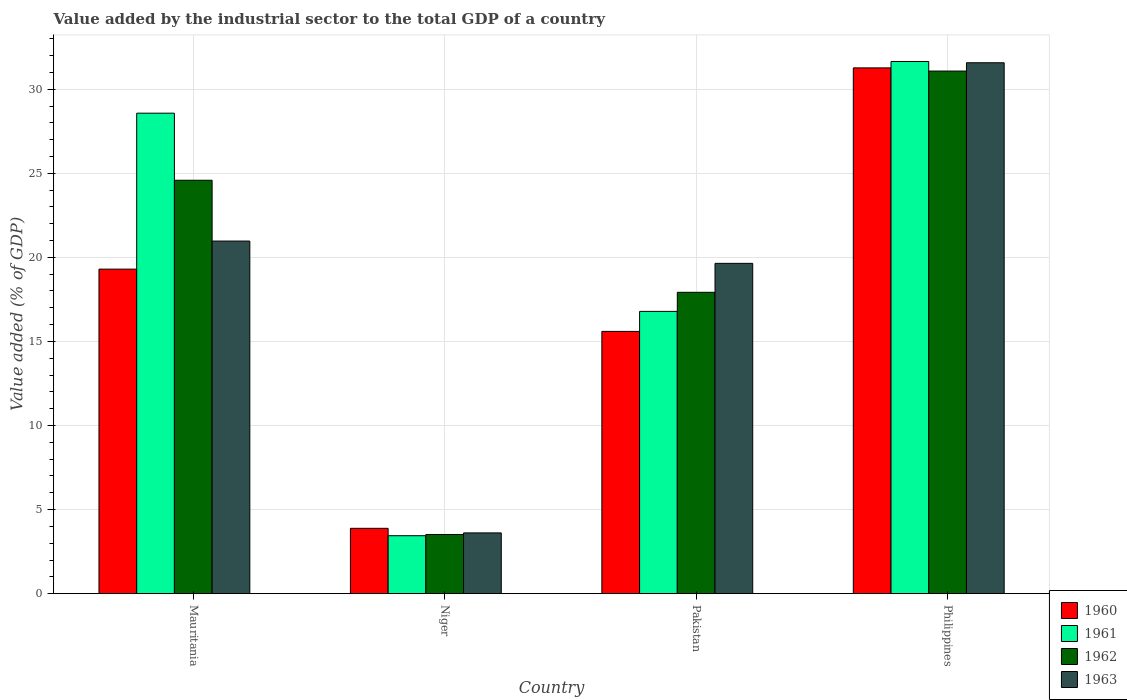How many different coloured bars are there?
Your response must be concise. 4. Are the number of bars per tick equal to the number of legend labels?
Make the answer very short. Yes. Are the number of bars on each tick of the X-axis equal?
Ensure brevity in your answer.  Yes. How many bars are there on the 4th tick from the left?
Your response must be concise. 4. What is the label of the 1st group of bars from the left?
Ensure brevity in your answer.  Mauritania. In how many cases, is the number of bars for a given country not equal to the number of legend labels?
Provide a succinct answer. 0. What is the value added by the industrial sector to the total GDP in 1961 in Niger?
Provide a succinct answer. 3.45. Across all countries, what is the maximum value added by the industrial sector to the total GDP in 1963?
Provide a short and direct response. 31.57. Across all countries, what is the minimum value added by the industrial sector to the total GDP in 1962?
Give a very brief answer. 3.52. In which country was the value added by the industrial sector to the total GDP in 1962 minimum?
Keep it short and to the point. Niger. What is the total value added by the industrial sector to the total GDP in 1960 in the graph?
Offer a terse response. 70.05. What is the difference between the value added by the industrial sector to the total GDP in 1961 in Niger and that in Pakistan?
Provide a short and direct response. -13.34. What is the difference between the value added by the industrial sector to the total GDP in 1963 in Niger and the value added by the industrial sector to the total GDP in 1960 in Philippines?
Offer a very short reply. -27.65. What is the average value added by the industrial sector to the total GDP in 1961 per country?
Ensure brevity in your answer.  20.11. What is the difference between the value added by the industrial sector to the total GDP of/in 1960 and value added by the industrial sector to the total GDP of/in 1963 in Niger?
Keep it short and to the point. 0.27. In how many countries, is the value added by the industrial sector to the total GDP in 1961 greater than 17 %?
Your answer should be very brief. 2. What is the ratio of the value added by the industrial sector to the total GDP in 1960 in Mauritania to that in Philippines?
Make the answer very short. 0.62. Is the difference between the value added by the industrial sector to the total GDP in 1960 in Pakistan and Philippines greater than the difference between the value added by the industrial sector to the total GDP in 1963 in Pakistan and Philippines?
Your answer should be compact. No. What is the difference between the highest and the second highest value added by the industrial sector to the total GDP in 1962?
Ensure brevity in your answer.  6.66. What is the difference between the highest and the lowest value added by the industrial sector to the total GDP in 1963?
Give a very brief answer. 27.96. In how many countries, is the value added by the industrial sector to the total GDP in 1961 greater than the average value added by the industrial sector to the total GDP in 1961 taken over all countries?
Your answer should be very brief. 2. Is the sum of the value added by the industrial sector to the total GDP in 1960 in Niger and Philippines greater than the maximum value added by the industrial sector to the total GDP in 1961 across all countries?
Make the answer very short. Yes. Is it the case that in every country, the sum of the value added by the industrial sector to the total GDP in 1961 and value added by the industrial sector to the total GDP in 1962 is greater than the sum of value added by the industrial sector to the total GDP in 1960 and value added by the industrial sector to the total GDP in 1963?
Give a very brief answer. No. What does the 1st bar from the left in Niger represents?
Your answer should be very brief. 1960. Is it the case that in every country, the sum of the value added by the industrial sector to the total GDP in 1960 and value added by the industrial sector to the total GDP in 1962 is greater than the value added by the industrial sector to the total GDP in 1963?
Your answer should be very brief. Yes. How many bars are there?
Offer a terse response. 16. Are all the bars in the graph horizontal?
Offer a terse response. No. Are the values on the major ticks of Y-axis written in scientific E-notation?
Offer a very short reply. No. Does the graph contain any zero values?
Provide a short and direct response. No. Does the graph contain grids?
Your answer should be very brief. Yes. Where does the legend appear in the graph?
Your answer should be compact. Bottom right. How many legend labels are there?
Your response must be concise. 4. What is the title of the graph?
Offer a terse response. Value added by the industrial sector to the total GDP of a country. Does "1994" appear as one of the legend labels in the graph?
Offer a very short reply. No. What is the label or title of the X-axis?
Keep it short and to the point. Country. What is the label or title of the Y-axis?
Your answer should be compact. Value added (% of GDP). What is the Value added (% of GDP) in 1960 in Mauritania?
Make the answer very short. 19.3. What is the Value added (% of GDP) in 1961 in Mauritania?
Ensure brevity in your answer.  28.57. What is the Value added (% of GDP) of 1962 in Mauritania?
Make the answer very short. 24.59. What is the Value added (% of GDP) of 1963 in Mauritania?
Offer a terse response. 20.97. What is the Value added (% of GDP) of 1960 in Niger?
Your response must be concise. 3.89. What is the Value added (% of GDP) of 1961 in Niger?
Give a very brief answer. 3.45. What is the Value added (% of GDP) in 1962 in Niger?
Provide a succinct answer. 3.52. What is the Value added (% of GDP) in 1963 in Niger?
Provide a succinct answer. 3.61. What is the Value added (% of GDP) of 1960 in Pakistan?
Your response must be concise. 15.6. What is the Value added (% of GDP) of 1961 in Pakistan?
Keep it short and to the point. 16.79. What is the Value added (% of GDP) in 1962 in Pakistan?
Your response must be concise. 17.92. What is the Value added (% of GDP) of 1963 in Pakistan?
Your response must be concise. 19.64. What is the Value added (% of GDP) of 1960 in Philippines?
Offer a very short reply. 31.27. What is the Value added (% of GDP) of 1961 in Philippines?
Give a very brief answer. 31.65. What is the Value added (% of GDP) in 1962 in Philippines?
Your answer should be compact. 31.08. What is the Value added (% of GDP) in 1963 in Philippines?
Offer a terse response. 31.57. Across all countries, what is the maximum Value added (% of GDP) in 1960?
Ensure brevity in your answer.  31.27. Across all countries, what is the maximum Value added (% of GDP) of 1961?
Your answer should be compact. 31.65. Across all countries, what is the maximum Value added (% of GDP) of 1962?
Your response must be concise. 31.08. Across all countries, what is the maximum Value added (% of GDP) in 1963?
Keep it short and to the point. 31.57. Across all countries, what is the minimum Value added (% of GDP) in 1960?
Offer a terse response. 3.89. Across all countries, what is the minimum Value added (% of GDP) of 1961?
Keep it short and to the point. 3.45. Across all countries, what is the minimum Value added (% of GDP) of 1962?
Provide a short and direct response. 3.52. Across all countries, what is the minimum Value added (% of GDP) of 1963?
Offer a terse response. 3.61. What is the total Value added (% of GDP) of 1960 in the graph?
Give a very brief answer. 70.05. What is the total Value added (% of GDP) in 1961 in the graph?
Offer a very short reply. 80.46. What is the total Value added (% of GDP) in 1962 in the graph?
Provide a succinct answer. 77.11. What is the total Value added (% of GDP) in 1963 in the graph?
Ensure brevity in your answer.  75.8. What is the difference between the Value added (% of GDP) of 1960 in Mauritania and that in Niger?
Offer a terse response. 15.41. What is the difference between the Value added (% of GDP) in 1961 in Mauritania and that in Niger?
Your answer should be very brief. 25.13. What is the difference between the Value added (% of GDP) in 1962 in Mauritania and that in Niger?
Your response must be concise. 21.07. What is the difference between the Value added (% of GDP) in 1963 in Mauritania and that in Niger?
Offer a very short reply. 17.36. What is the difference between the Value added (% of GDP) in 1960 in Mauritania and that in Pakistan?
Make the answer very short. 3.7. What is the difference between the Value added (% of GDP) of 1961 in Mauritania and that in Pakistan?
Ensure brevity in your answer.  11.79. What is the difference between the Value added (% of GDP) of 1962 in Mauritania and that in Pakistan?
Make the answer very short. 6.66. What is the difference between the Value added (% of GDP) in 1963 in Mauritania and that in Pakistan?
Provide a short and direct response. 1.33. What is the difference between the Value added (% of GDP) in 1960 in Mauritania and that in Philippines?
Ensure brevity in your answer.  -11.97. What is the difference between the Value added (% of GDP) of 1961 in Mauritania and that in Philippines?
Keep it short and to the point. -3.07. What is the difference between the Value added (% of GDP) in 1962 in Mauritania and that in Philippines?
Ensure brevity in your answer.  -6.49. What is the difference between the Value added (% of GDP) in 1963 in Mauritania and that in Philippines?
Your answer should be very brief. -10.6. What is the difference between the Value added (% of GDP) in 1960 in Niger and that in Pakistan?
Make the answer very short. -11.71. What is the difference between the Value added (% of GDP) of 1961 in Niger and that in Pakistan?
Provide a succinct answer. -13.34. What is the difference between the Value added (% of GDP) in 1962 in Niger and that in Pakistan?
Offer a very short reply. -14.4. What is the difference between the Value added (% of GDP) of 1963 in Niger and that in Pakistan?
Give a very brief answer. -16.03. What is the difference between the Value added (% of GDP) in 1960 in Niger and that in Philippines?
Give a very brief answer. -27.38. What is the difference between the Value added (% of GDP) of 1961 in Niger and that in Philippines?
Offer a terse response. -28.2. What is the difference between the Value added (% of GDP) in 1962 in Niger and that in Philippines?
Provide a short and direct response. -27.56. What is the difference between the Value added (% of GDP) of 1963 in Niger and that in Philippines?
Provide a succinct answer. -27.96. What is the difference between the Value added (% of GDP) in 1960 in Pakistan and that in Philippines?
Make the answer very short. -15.67. What is the difference between the Value added (% of GDP) in 1961 in Pakistan and that in Philippines?
Ensure brevity in your answer.  -14.86. What is the difference between the Value added (% of GDP) in 1962 in Pakistan and that in Philippines?
Provide a succinct answer. -13.16. What is the difference between the Value added (% of GDP) in 1963 in Pakistan and that in Philippines?
Keep it short and to the point. -11.93. What is the difference between the Value added (% of GDP) in 1960 in Mauritania and the Value added (% of GDP) in 1961 in Niger?
Ensure brevity in your answer.  15.85. What is the difference between the Value added (% of GDP) of 1960 in Mauritania and the Value added (% of GDP) of 1962 in Niger?
Your answer should be very brief. 15.78. What is the difference between the Value added (% of GDP) in 1960 in Mauritania and the Value added (% of GDP) in 1963 in Niger?
Make the answer very short. 15.69. What is the difference between the Value added (% of GDP) of 1961 in Mauritania and the Value added (% of GDP) of 1962 in Niger?
Provide a succinct answer. 25.05. What is the difference between the Value added (% of GDP) of 1961 in Mauritania and the Value added (% of GDP) of 1963 in Niger?
Offer a terse response. 24.96. What is the difference between the Value added (% of GDP) in 1962 in Mauritania and the Value added (% of GDP) in 1963 in Niger?
Your response must be concise. 20.97. What is the difference between the Value added (% of GDP) of 1960 in Mauritania and the Value added (% of GDP) of 1961 in Pakistan?
Offer a terse response. 2.51. What is the difference between the Value added (% of GDP) of 1960 in Mauritania and the Value added (% of GDP) of 1962 in Pakistan?
Your answer should be compact. 1.38. What is the difference between the Value added (% of GDP) in 1960 in Mauritania and the Value added (% of GDP) in 1963 in Pakistan?
Offer a terse response. -0.34. What is the difference between the Value added (% of GDP) of 1961 in Mauritania and the Value added (% of GDP) of 1962 in Pakistan?
Make the answer very short. 10.65. What is the difference between the Value added (% of GDP) in 1961 in Mauritania and the Value added (% of GDP) in 1963 in Pakistan?
Give a very brief answer. 8.93. What is the difference between the Value added (% of GDP) of 1962 in Mauritania and the Value added (% of GDP) of 1963 in Pakistan?
Give a very brief answer. 4.94. What is the difference between the Value added (% of GDP) of 1960 in Mauritania and the Value added (% of GDP) of 1961 in Philippines?
Provide a short and direct response. -12.35. What is the difference between the Value added (% of GDP) of 1960 in Mauritania and the Value added (% of GDP) of 1962 in Philippines?
Your answer should be very brief. -11.78. What is the difference between the Value added (% of GDP) in 1960 in Mauritania and the Value added (% of GDP) in 1963 in Philippines?
Your answer should be very brief. -12.27. What is the difference between the Value added (% of GDP) in 1961 in Mauritania and the Value added (% of GDP) in 1962 in Philippines?
Make the answer very short. -2.51. What is the difference between the Value added (% of GDP) in 1961 in Mauritania and the Value added (% of GDP) in 1963 in Philippines?
Give a very brief answer. -3. What is the difference between the Value added (% of GDP) in 1962 in Mauritania and the Value added (% of GDP) in 1963 in Philippines?
Offer a terse response. -6.99. What is the difference between the Value added (% of GDP) of 1960 in Niger and the Value added (% of GDP) of 1961 in Pakistan?
Your answer should be very brief. -12.9. What is the difference between the Value added (% of GDP) of 1960 in Niger and the Value added (% of GDP) of 1962 in Pakistan?
Your response must be concise. -14.04. What is the difference between the Value added (% of GDP) of 1960 in Niger and the Value added (% of GDP) of 1963 in Pakistan?
Your response must be concise. -15.76. What is the difference between the Value added (% of GDP) of 1961 in Niger and the Value added (% of GDP) of 1962 in Pakistan?
Provide a short and direct response. -14.48. What is the difference between the Value added (% of GDP) of 1961 in Niger and the Value added (% of GDP) of 1963 in Pakistan?
Make the answer very short. -16.2. What is the difference between the Value added (% of GDP) in 1962 in Niger and the Value added (% of GDP) in 1963 in Pakistan?
Provide a succinct answer. -16.12. What is the difference between the Value added (% of GDP) of 1960 in Niger and the Value added (% of GDP) of 1961 in Philippines?
Your answer should be very brief. -27.76. What is the difference between the Value added (% of GDP) in 1960 in Niger and the Value added (% of GDP) in 1962 in Philippines?
Your response must be concise. -27.19. What is the difference between the Value added (% of GDP) of 1960 in Niger and the Value added (% of GDP) of 1963 in Philippines?
Make the answer very short. -27.69. What is the difference between the Value added (% of GDP) in 1961 in Niger and the Value added (% of GDP) in 1962 in Philippines?
Give a very brief answer. -27.63. What is the difference between the Value added (% of GDP) of 1961 in Niger and the Value added (% of GDP) of 1963 in Philippines?
Offer a terse response. -28.13. What is the difference between the Value added (% of GDP) in 1962 in Niger and the Value added (% of GDP) in 1963 in Philippines?
Offer a very short reply. -28.05. What is the difference between the Value added (% of GDP) in 1960 in Pakistan and the Value added (% of GDP) in 1961 in Philippines?
Provide a succinct answer. -16.05. What is the difference between the Value added (% of GDP) of 1960 in Pakistan and the Value added (% of GDP) of 1962 in Philippines?
Provide a short and direct response. -15.48. What is the difference between the Value added (% of GDP) in 1960 in Pakistan and the Value added (% of GDP) in 1963 in Philippines?
Offer a very short reply. -15.98. What is the difference between the Value added (% of GDP) of 1961 in Pakistan and the Value added (% of GDP) of 1962 in Philippines?
Make the answer very short. -14.29. What is the difference between the Value added (% of GDP) in 1961 in Pakistan and the Value added (% of GDP) in 1963 in Philippines?
Make the answer very short. -14.79. What is the difference between the Value added (% of GDP) of 1962 in Pakistan and the Value added (% of GDP) of 1963 in Philippines?
Provide a short and direct response. -13.65. What is the average Value added (% of GDP) of 1960 per country?
Your answer should be compact. 17.51. What is the average Value added (% of GDP) in 1961 per country?
Keep it short and to the point. 20.11. What is the average Value added (% of GDP) of 1962 per country?
Offer a very short reply. 19.28. What is the average Value added (% of GDP) of 1963 per country?
Provide a succinct answer. 18.95. What is the difference between the Value added (% of GDP) in 1960 and Value added (% of GDP) in 1961 in Mauritania?
Provide a short and direct response. -9.27. What is the difference between the Value added (% of GDP) in 1960 and Value added (% of GDP) in 1962 in Mauritania?
Your answer should be compact. -5.29. What is the difference between the Value added (% of GDP) of 1960 and Value added (% of GDP) of 1963 in Mauritania?
Your answer should be very brief. -1.67. What is the difference between the Value added (% of GDP) of 1961 and Value added (% of GDP) of 1962 in Mauritania?
Give a very brief answer. 3.99. What is the difference between the Value added (% of GDP) in 1961 and Value added (% of GDP) in 1963 in Mauritania?
Your response must be concise. 7.6. What is the difference between the Value added (% of GDP) of 1962 and Value added (% of GDP) of 1963 in Mauritania?
Provide a succinct answer. 3.62. What is the difference between the Value added (% of GDP) of 1960 and Value added (% of GDP) of 1961 in Niger?
Keep it short and to the point. 0.44. What is the difference between the Value added (% of GDP) of 1960 and Value added (% of GDP) of 1962 in Niger?
Provide a short and direct response. 0.37. What is the difference between the Value added (% of GDP) of 1960 and Value added (% of GDP) of 1963 in Niger?
Make the answer very short. 0.27. What is the difference between the Value added (% of GDP) of 1961 and Value added (% of GDP) of 1962 in Niger?
Provide a short and direct response. -0.07. What is the difference between the Value added (% of GDP) of 1961 and Value added (% of GDP) of 1963 in Niger?
Provide a short and direct response. -0.17. What is the difference between the Value added (% of GDP) of 1962 and Value added (% of GDP) of 1963 in Niger?
Your answer should be very brief. -0.09. What is the difference between the Value added (% of GDP) in 1960 and Value added (% of GDP) in 1961 in Pakistan?
Keep it short and to the point. -1.19. What is the difference between the Value added (% of GDP) of 1960 and Value added (% of GDP) of 1962 in Pakistan?
Offer a terse response. -2.33. What is the difference between the Value added (% of GDP) of 1960 and Value added (% of GDP) of 1963 in Pakistan?
Provide a short and direct response. -4.05. What is the difference between the Value added (% of GDP) in 1961 and Value added (% of GDP) in 1962 in Pakistan?
Your answer should be very brief. -1.14. What is the difference between the Value added (% of GDP) in 1961 and Value added (% of GDP) in 1963 in Pakistan?
Provide a succinct answer. -2.86. What is the difference between the Value added (% of GDP) in 1962 and Value added (% of GDP) in 1963 in Pakistan?
Your answer should be compact. -1.72. What is the difference between the Value added (% of GDP) of 1960 and Value added (% of GDP) of 1961 in Philippines?
Provide a succinct answer. -0.38. What is the difference between the Value added (% of GDP) of 1960 and Value added (% of GDP) of 1962 in Philippines?
Make the answer very short. 0.19. What is the difference between the Value added (% of GDP) in 1960 and Value added (% of GDP) in 1963 in Philippines?
Your answer should be very brief. -0.3. What is the difference between the Value added (% of GDP) in 1961 and Value added (% of GDP) in 1962 in Philippines?
Provide a succinct answer. 0.57. What is the difference between the Value added (% of GDP) in 1961 and Value added (% of GDP) in 1963 in Philippines?
Your response must be concise. 0.08. What is the difference between the Value added (% of GDP) of 1962 and Value added (% of GDP) of 1963 in Philippines?
Your answer should be compact. -0.49. What is the ratio of the Value added (% of GDP) of 1960 in Mauritania to that in Niger?
Give a very brief answer. 4.97. What is the ratio of the Value added (% of GDP) in 1961 in Mauritania to that in Niger?
Make the answer very short. 8.29. What is the ratio of the Value added (% of GDP) in 1962 in Mauritania to that in Niger?
Offer a terse response. 6.99. What is the ratio of the Value added (% of GDP) in 1963 in Mauritania to that in Niger?
Ensure brevity in your answer.  5.8. What is the ratio of the Value added (% of GDP) in 1960 in Mauritania to that in Pakistan?
Offer a terse response. 1.24. What is the ratio of the Value added (% of GDP) of 1961 in Mauritania to that in Pakistan?
Provide a short and direct response. 1.7. What is the ratio of the Value added (% of GDP) in 1962 in Mauritania to that in Pakistan?
Provide a short and direct response. 1.37. What is the ratio of the Value added (% of GDP) of 1963 in Mauritania to that in Pakistan?
Keep it short and to the point. 1.07. What is the ratio of the Value added (% of GDP) of 1960 in Mauritania to that in Philippines?
Make the answer very short. 0.62. What is the ratio of the Value added (% of GDP) of 1961 in Mauritania to that in Philippines?
Your answer should be compact. 0.9. What is the ratio of the Value added (% of GDP) of 1962 in Mauritania to that in Philippines?
Provide a short and direct response. 0.79. What is the ratio of the Value added (% of GDP) of 1963 in Mauritania to that in Philippines?
Make the answer very short. 0.66. What is the ratio of the Value added (% of GDP) of 1960 in Niger to that in Pakistan?
Make the answer very short. 0.25. What is the ratio of the Value added (% of GDP) in 1961 in Niger to that in Pakistan?
Offer a terse response. 0.21. What is the ratio of the Value added (% of GDP) in 1962 in Niger to that in Pakistan?
Offer a very short reply. 0.2. What is the ratio of the Value added (% of GDP) of 1963 in Niger to that in Pakistan?
Offer a terse response. 0.18. What is the ratio of the Value added (% of GDP) in 1960 in Niger to that in Philippines?
Offer a very short reply. 0.12. What is the ratio of the Value added (% of GDP) in 1961 in Niger to that in Philippines?
Give a very brief answer. 0.11. What is the ratio of the Value added (% of GDP) of 1962 in Niger to that in Philippines?
Your answer should be compact. 0.11. What is the ratio of the Value added (% of GDP) of 1963 in Niger to that in Philippines?
Make the answer very short. 0.11. What is the ratio of the Value added (% of GDP) in 1960 in Pakistan to that in Philippines?
Offer a very short reply. 0.5. What is the ratio of the Value added (% of GDP) of 1961 in Pakistan to that in Philippines?
Offer a terse response. 0.53. What is the ratio of the Value added (% of GDP) of 1962 in Pakistan to that in Philippines?
Make the answer very short. 0.58. What is the ratio of the Value added (% of GDP) of 1963 in Pakistan to that in Philippines?
Keep it short and to the point. 0.62. What is the difference between the highest and the second highest Value added (% of GDP) of 1960?
Ensure brevity in your answer.  11.97. What is the difference between the highest and the second highest Value added (% of GDP) in 1961?
Make the answer very short. 3.07. What is the difference between the highest and the second highest Value added (% of GDP) in 1962?
Provide a succinct answer. 6.49. What is the difference between the highest and the second highest Value added (% of GDP) of 1963?
Your response must be concise. 10.6. What is the difference between the highest and the lowest Value added (% of GDP) of 1960?
Ensure brevity in your answer.  27.38. What is the difference between the highest and the lowest Value added (% of GDP) of 1961?
Provide a succinct answer. 28.2. What is the difference between the highest and the lowest Value added (% of GDP) in 1962?
Keep it short and to the point. 27.56. What is the difference between the highest and the lowest Value added (% of GDP) of 1963?
Provide a short and direct response. 27.96. 